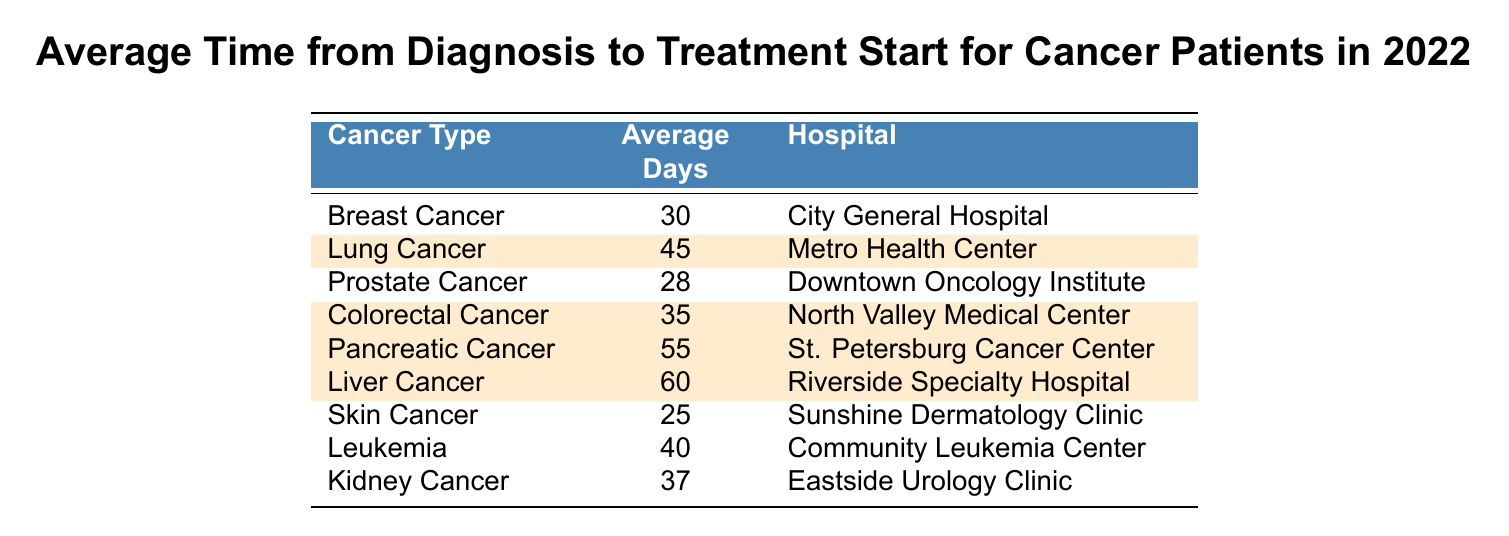What's the average time for treatment to start for lung cancer patients? The table shows that the average time from diagnosis to treatment start for lung cancer is 45 days.
Answer: 45 days Which hospital has the longest average time to treatment start for cancer patients? By reviewing the table, we find that liver cancer has the longest average time at 60 days, which is provided by Riverside Specialty Hospital.
Answer: Riverside Specialty Hospital Is the average time for prostate cancer treatment longer than that for colorectal cancer? The average time for prostate cancer treatment is 28 days, while colorectal cancer treatment takes 35 days. Therefore, prostate cancer treatment is shorter than colorectal cancer treatment.
Answer: No What is the average time from diagnosis to treatment start for pancreatic cancer and liver cancer combined? Pancreatic cancer takes 55 days, and liver cancer takes 60 days. Adding these gives 55 + 60 = 115 days. To find the average, we divide by the number of cancer types, which is 2: 115 / 2 = 57.5 days.
Answer: 57.5 days Which type of cancer has the shortest average time to treatment start, and how much shorter is it compared to lung cancer? The shortest average time is for skin cancer at 25 days. Lung cancer treatment takes 45 days, so the difference is 45 - 25 = 20 days.
Answer: Skin cancer; 20 days shorter How many cancer types have an average treatment start time less than 40 days? The table shows skin cancer (25 days) and prostate cancer (28 days) as the only types under 40 days. Therefore, there are 2 types in total.
Answer: 2 types What is the average time to treatment start for all cancer types listed in the table? We first sum the average days for all cancer types: 30 + 45 + 28 + 35 + 55 + 60 + 25 + 40 + 37 =  355 days. There are 9 cancer types, so the average is 355 / 9 = 39.44 days.
Answer: 39.44 days Is it true that all highlighted cancer types have an average time to treatment start above 50 days? The highlighted cancer types are lung cancer (45 days), colorectal cancer (35 days), pancreatic cancer (55 days), and liver cancer (60 days). Since lung cancer and colorectal cancer are below 50 days, the statement is false.
Answer: No What is the difference in average treatment start time between the longest (liver cancer) and the shortest (skin cancer)? Liver cancer takes 60 days while skin cancer takes 25 days. Their difference is 60 - 25 = 35 days.
Answer: 35 days 